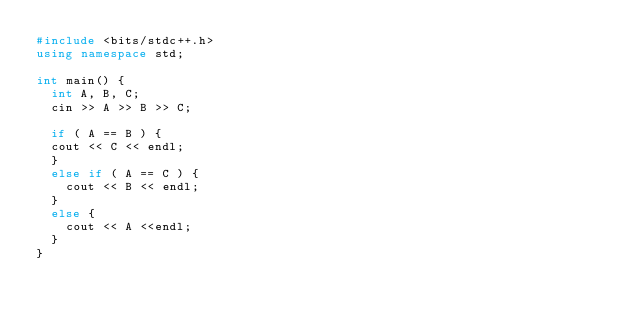Convert code to text. <code><loc_0><loc_0><loc_500><loc_500><_C++_>#include <bits/stdc++.h>
using namespace std;

int main() {
  int A, B, C;
  cin >> A >> B >> C;
  
  if ( A == B ) {
  cout << C << endl;
  }
  else if ( A == C ) {
    cout << B << endl;
  }
  else {
    cout << A <<endl;
  }
}</code> 